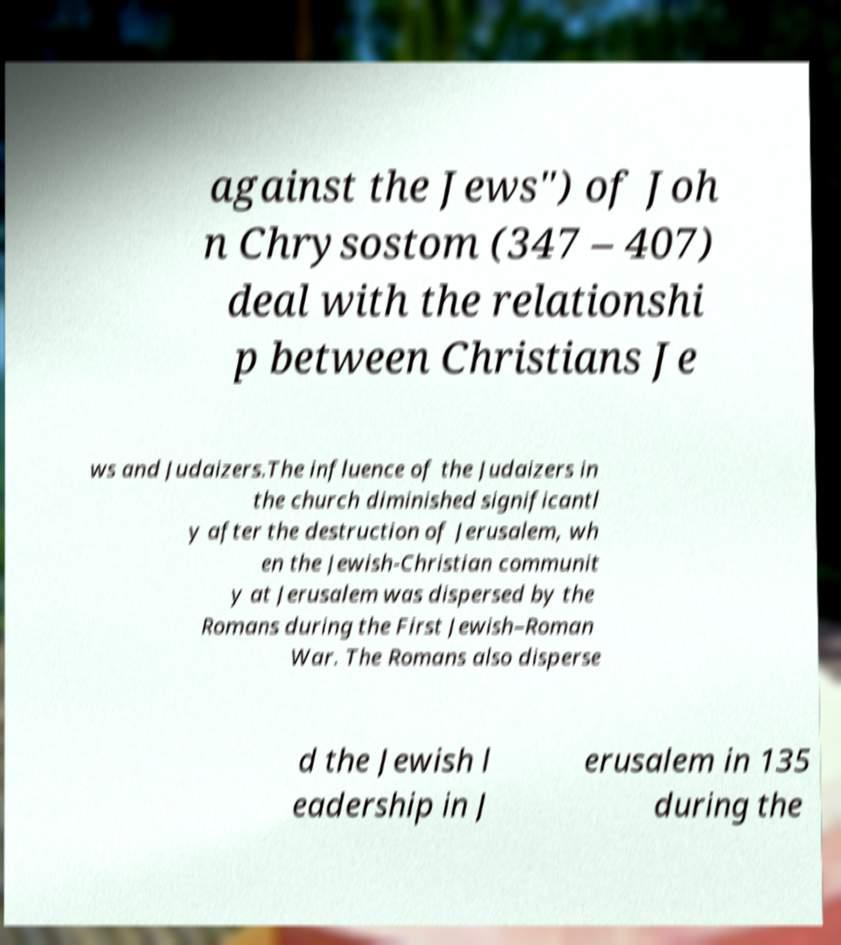Could you extract and type out the text from this image? against the Jews") of Joh n Chrysostom (347 – 407) deal with the relationshi p between Christians Je ws and Judaizers.The influence of the Judaizers in the church diminished significantl y after the destruction of Jerusalem, wh en the Jewish-Christian communit y at Jerusalem was dispersed by the Romans during the First Jewish–Roman War. The Romans also disperse d the Jewish l eadership in J erusalem in 135 during the 